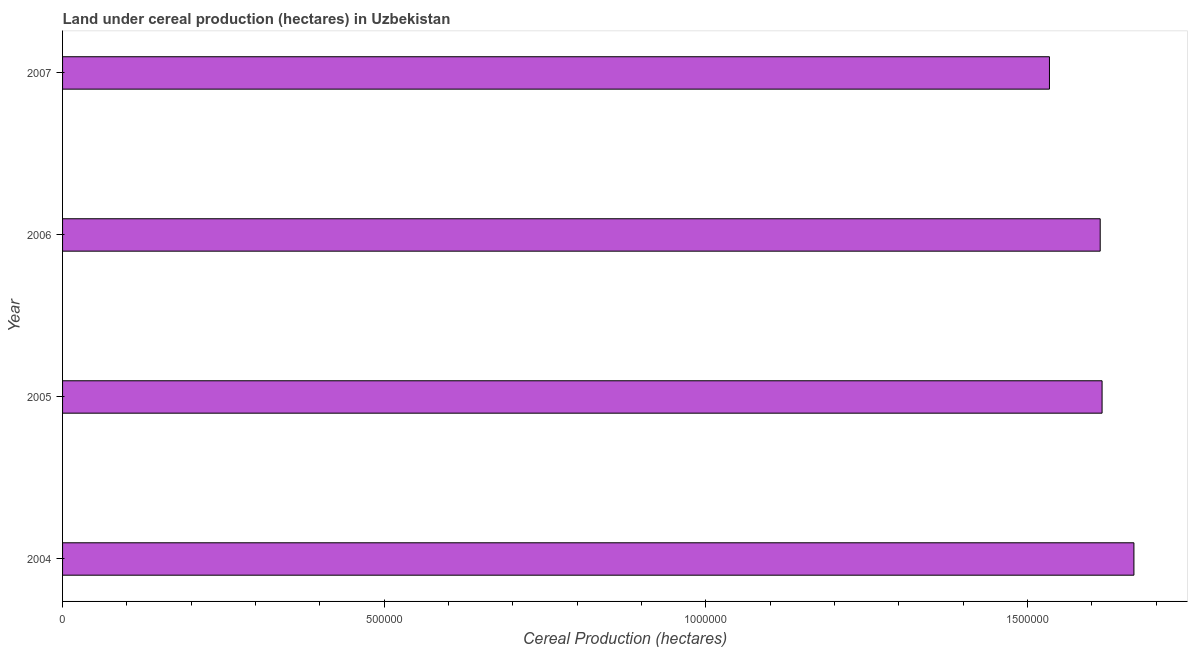Does the graph contain grids?
Your answer should be compact. No. What is the title of the graph?
Provide a short and direct response. Land under cereal production (hectares) in Uzbekistan. What is the label or title of the X-axis?
Provide a succinct answer. Cereal Production (hectares). What is the land under cereal production in 2007?
Give a very brief answer. 1.53e+06. Across all years, what is the maximum land under cereal production?
Your answer should be very brief. 1.67e+06. Across all years, what is the minimum land under cereal production?
Your answer should be compact. 1.53e+06. In which year was the land under cereal production minimum?
Provide a succinct answer. 2007. What is the sum of the land under cereal production?
Give a very brief answer. 6.43e+06. What is the difference between the land under cereal production in 2004 and 2005?
Provide a succinct answer. 4.95e+04. What is the average land under cereal production per year?
Provide a succinct answer. 1.61e+06. What is the median land under cereal production?
Provide a short and direct response. 1.61e+06. In how many years, is the land under cereal production greater than 1000000 hectares?
Provide a short and direct response. 4. Do a majority of the years between 2004 and 2005 (inclusive) have land under cereal production greater than 1100000 hectares?
Ensure brevity in your answer.  Yes. What is the ratio of the land under cereal production in 2004 to that in 2006?
Your answer should be compact. 1.03. Is the land under cereal production in 2004 less than that in 2005?
Ensure brevity in your answer.  No. What is the difference between the highest and the second highest land under cereal production?
Keep it short and to the point. 4.95e+04. Is the sum of the land under cereal production in 2004 and 2006 greater than the maximum land under cereal production across all years?
Your response must be concise. Yes. What is the difference between the highest and the lowest land under cereal production?
Give a very brief answer. 1.31e+05. How many bars are there?
Offer a terse response. 4. Are all the bars in the graph horizontal?
Ensure brevity in your answer.  Yes. How many years are there in the graph?
Make the answer very short. 4. What is the difference between two consecutive major ticks on the X-axis?
Keep it short and to the point. 5.00e+05. Are the values on the major ticks of X-axis written in scientific E-notation?
Your answer should be compact. No. What is the Cereal Production (hectares) in 2004?
Offer a very short reply. 1.67e+06. What is the Cereal Production (hectares) in 2005?
Keep it short and to the point. 1.62e+06. What is the Cereal Production (hectares) of 2006?
Ensure brevity in your answer.  1.61e+06. What is the Cereal Production (hectares) in 2007?
Your answer should be compact. 1.53e+06. What is the difference between the Cereal Production (hectares) in 2004 and 2005?
Make the answer very short. 4.95e+04. What is the difference between the Cereal Production (hectares) in 2004 and 2006?
Your answer should be very brief. 5.24e+04. What is the difference between the Cereal Production (hectares) in 2004 and 2007?
Your answer should be very brief. 1.31e+05. What is the difference between the Cereal Production (hectares) in 2005 and 2006?
Your answer should be compact. 2920. What is the difference between the Cereal Production (hectares) in 2005 and 2007?
Ensure brevity in your answer.  8.18e+04. What is the difference between the Cereal Production (hectares) in 2006 and 2007?
Give a very brief answer. 7.89e+04. What is the ratio of the Cereal Production (hectares) in 2004 to that in 2005?
Your response must be concise. 1.03. What is the ratio of the Cereal Production (hectares) in 2004 to that in 2006?
Make the answer very short. 1.03. What is the ratio of the Cereal Production (hectares) in 2004 to that in 2007?
Your answer should be compact. 1.09. What is the ratio of the Cereal Production (hectares) in 2005 to that in 2006?
Ensure brevity in your answer.  1. What is the ratio of the Cereal Production (hectares) in 2005 to that in 2007?
Give a very brief answer. 1.05. What is the ratio of the Cereal Production (hectares) in 2006 to that in 2007?
Offer a terse response. 1.05. 